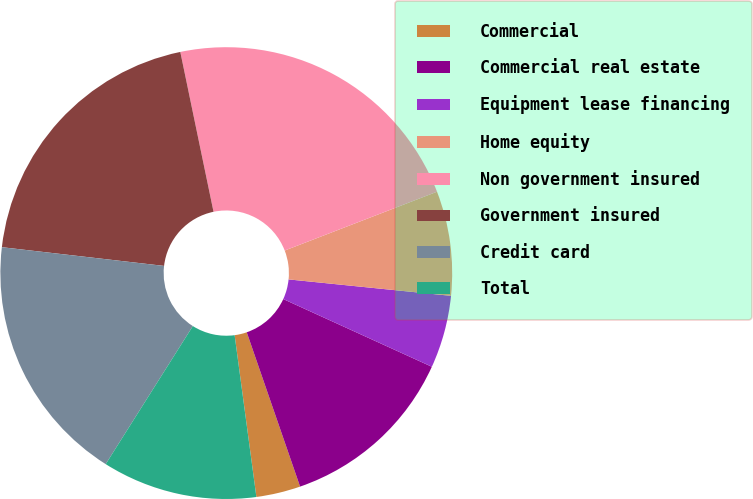Convert chart to OTSL. <chart><loc_0><loc_0><loc_500><loc_500><pie_chart><fcel>Commercial<fcel>Commercial real estate<fcel>Equipment lease financing<fcel>Home equity<fcel>Non government insured<fcel>Government insured<fcel>Credit card<fcel>Total<nl><fcel>3.17%<fcel>12.9%<fcel>5.2%<fcel>7.47%<fcel>22.4%<fcel>19.91%<fcel>17.87%<fcel>11.09%<nl></chart> 